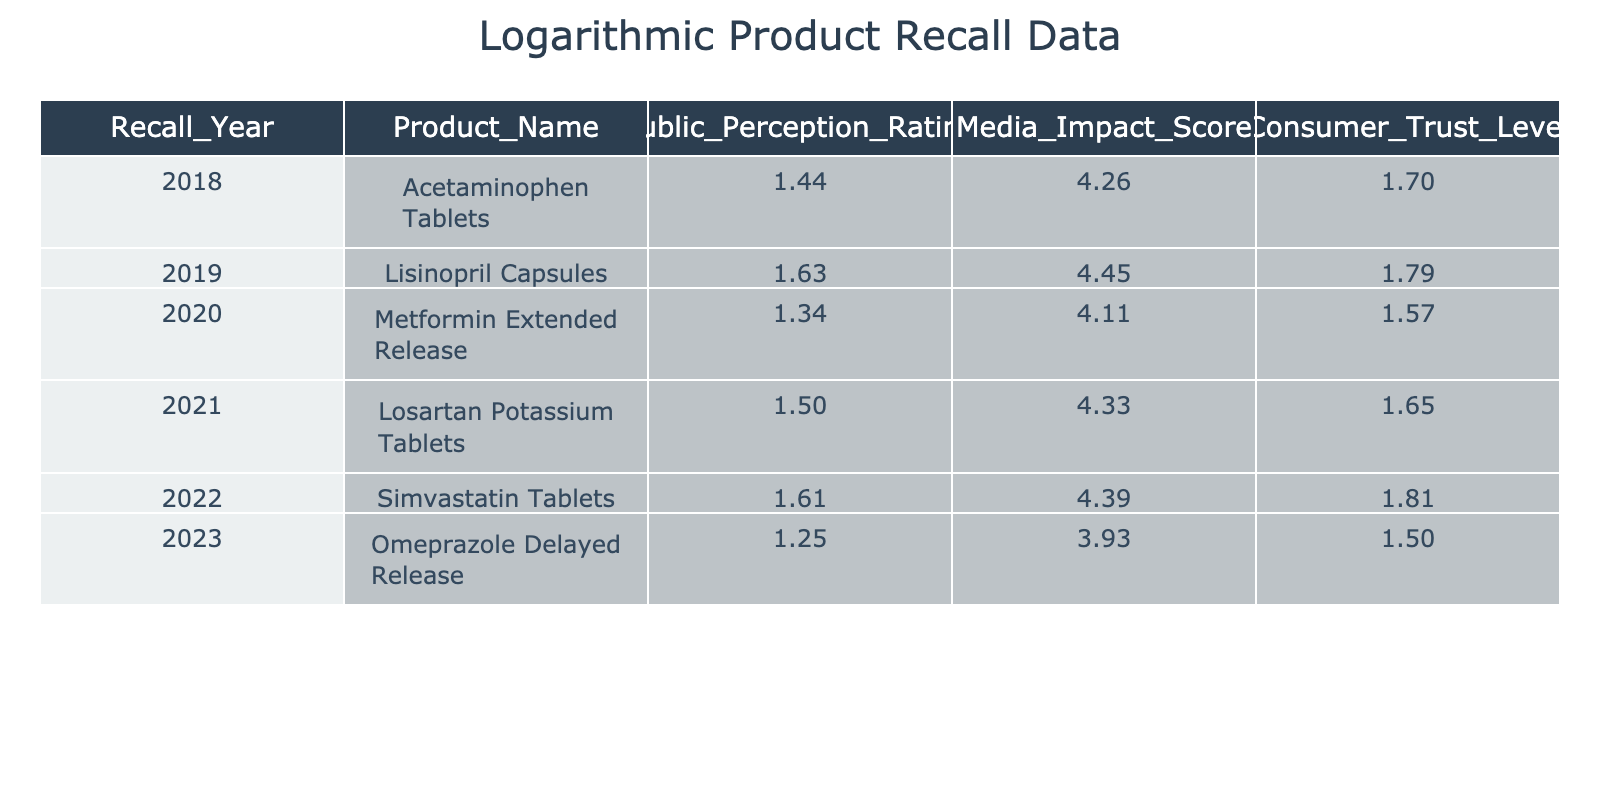What was the public perception rating for Omeprazole Delayed Release in 2023? The table shows that the public perception rating for Omeprazole Delayed Release in 2023 is 2.5. This is directly found by locating the row for the year 2023 and the corresponding product name.
Answer: 2.5 Which product had the highest public perception rating, and what was that rating? By examining the public perception ratings across all products in the table, Lisinopril Capsules in 2019 has the highest rating at 4.1. This is determined by comparing the values in the Public Perception Rating column.
Answer: Lisinopril Capsules, 4.1 True or False: The Media Impact Score for Simvastatin Tablets in 2022 is higher than that for Omeprazole Delayed Release in 2023. The Media Impact Score for Simvastatin Tablets in 2022 is 80, while for Omeprazole Delayed Release in 2023, it is 50. Since 80 is greater than 50, the statement is True.
Answer: True What is the difference in public perception rating between the product with the highest and lowest ratings? The highest public perception rating is 4.1 (Lisinopril Capsules), and the lowest is 2.5 (Omeprazole Delayed Release). The difference is calculated as 4.1 - 2.5 = 1.6. This requires identifying the highest and lowest values first, then subtracting them.
Answer: 1.6 What is the average public perception rating for the years listed? To find the average, we sum the public perception ratings: 3.2 + 4.1 + 2.8 + 3.5 + 4.0 + 2.5 = 20.1. There are 6 data points, so the average is 20.1 / 6 = 3.35. This involves finding the sum of all ratings and dividing by the number of entries.
Answer: 3.35 